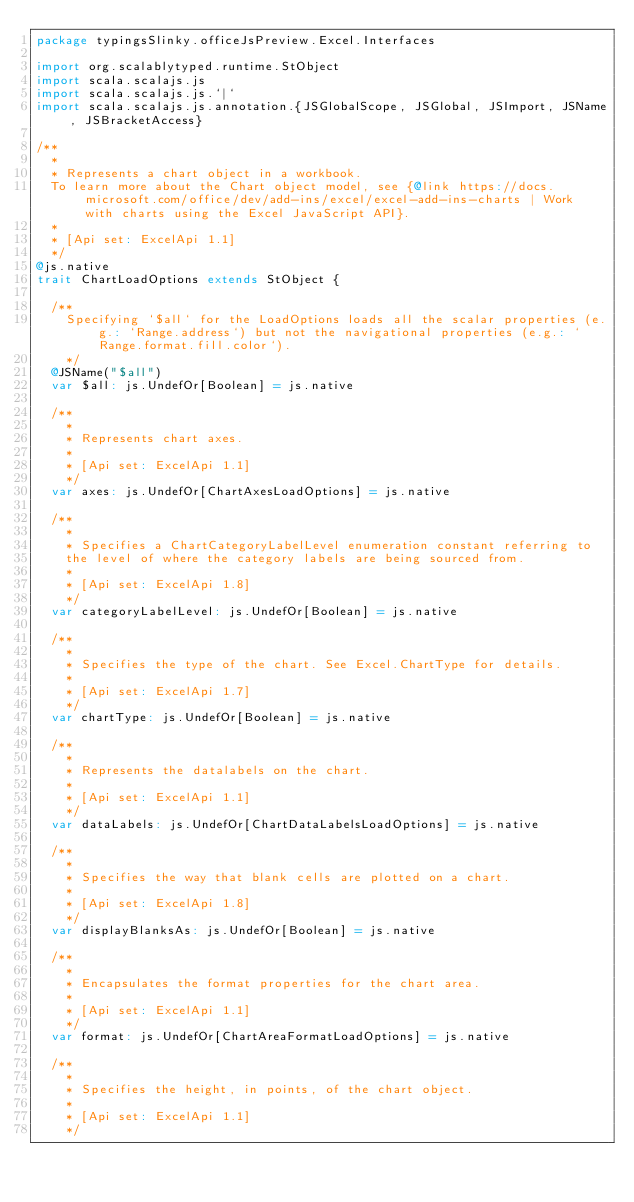<code> <loc_0><loc_0><loc_500><loc_500><_Scala_>package typingsSlinky.officeJsPreview.Excel.Interfaces

import org.scalablytyped.runtime.StObject
import scala.scalajs.js
import scala.scalajs.js.`|`
import scala.scalajs.js.annotation.{JSGlobalScope, JSGlobal, JSImport, JSName, JSBracketAccess}

/**
  *
  * Represents a chart object in a workbook.
  To learn more about the Chart object model, see {@link https://docs.microsoft.com/office/dev/add-ins/excel/excel-add-ins-charts | Work with charts using the Excel JavaScript API}.
  *
  * [Api set: ExcelApi 1.1]
  */
@js.native
trait ChartLoadOptions extends StObject {
  
  /**
    Specifying `$all` for the LoadOptions loads all the scalar properties (e.g.: `Range.address`) but not the navigational properties (e.g.: `Range.format.fill.color`).
    */
  @JSName("$all")
  var $all: js.UndefOr[Boolean] = js.native
  
  /**
    *
    * Represents chart axes.
    *
    * [Api set: ExcelApi 1.1]
    */
  var axes: js.UndefOr[ChartAxesLoadOptions] = js.native
  
  /**
    *
    * Specifies a ChartCategoryLabelLevel enumeration constant referring to
    the level of where the category labels are being sourced from.
    *
    * [Api set: ExcelApi 1.8]
    */
  var categoryLabelLevel: js.UndefOr[Boolean] = js.native
  
  /**
    *
    * Specifies the type of the chart. See Excel.ChartType for details.
    *
    * [Api set: ExcelApi 1.7]
    */
  var chartType: js.UndefOr[Boolean] = js.native
  
  /**
    *
    * Represents the datalabels on the chart.
    *
    * [Api set: ExcelApi 1.1]
    */
  var dataLabels: js.UndefOr[ChartDataLabelsLoadOptions] = js.native
  
  /**
    *
    * Specifies the way that blank cells are plotted on a chart.
    *
    * [Api set: ExcelApi 1.8]
    */
  var displayBlanksAs: js.UndefOr[Boolean] = js.native
  
  /**
    *
    * Encapsulates the format properties for the chart area.
    *
    * [Api set: ExcelApi 1.1]
    */
  var format: js.UndefOr[ChartAreaFormatLoadOptions] = js.native
  
  /**
    *
    * Specifies the height, in points, of the chart object.
    *
    * [Api set: ExcelApi 1.1]
    */</code> 